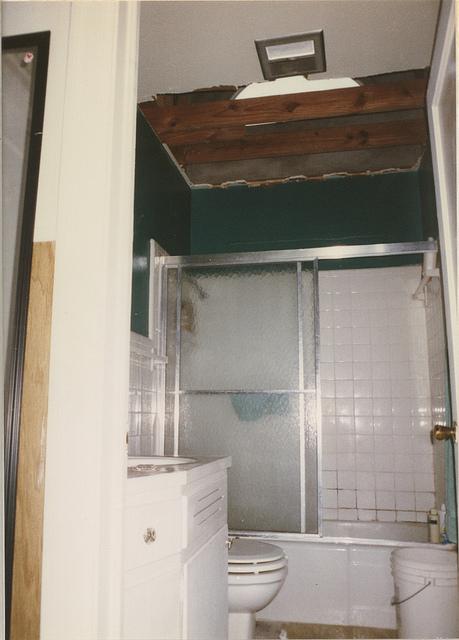What color is the tile?
Keep it brief. White. What room is this?
Give a very brief answer. Bathroom. Where is the toilet?
Short answer required. Bathroom. What color is the shower?
Keep it brief. White. Is the bathroom ceiling missing?
Keep it brief. Yes. What room is this labeled as?
Quick response, please. Bathroom. 